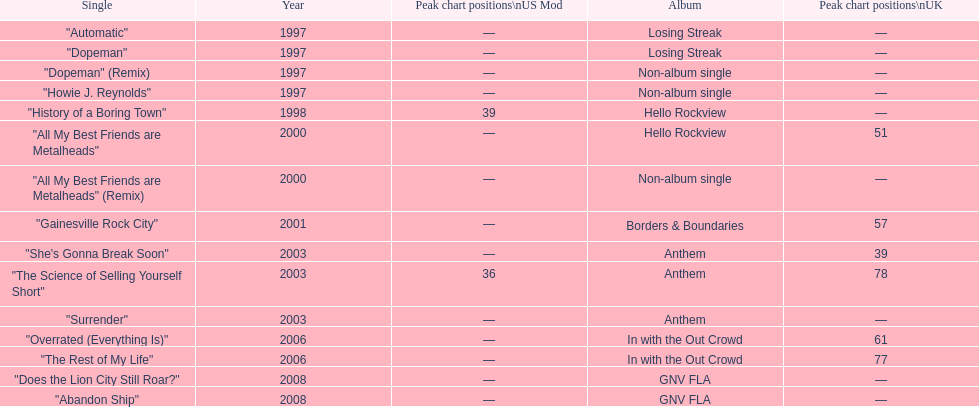Parse the table in full. {'header': ['Single', 'Year', 'Peak chart positions\\nUS Mod', 'Album', 'Peak chart positions\\nUK'], 'rows': [['"Automatic"', '1997', '—', 'Losing Streak', '—'], ['"Dopeman"', '1997', '—', 'Losing Streak', '—'], ['"Dopeman" (Remix)', '1997', '—', 'Non-album single', '—'], ['"Howie J. Reynolds"', '1997', '—', 'Non-album single', '—'], ['"History of a Boring Town"', '1998', '39', 'Hello Rockview', '—'], ['"All My Best Friends are Metalheads"', '2000', '—', 'Hello Rockview', '51'], ['"All My Best Friends are Metalheads" (Remix)', '2000', '—', 'Non-album single', '—'], ['"Gainesville Rock City"', '2001', '—', 'Borders & Boundaries', '57'], ['"She\'s Gonna Break Soon"', '2003', '—', 'Anthem', '39'], ['"The Science of Selling Yourself Short"', '2003', '36', 'Anthem', '78'], ['"Surrender"', '2003', '—', 'Anthem', '—'], ['"Overrated (Everything Is)"', '2006', '—', 'In with the Out Crowd', '61'], ['"The Rest of My Life"', '2006', '—', 'In with the Out Crowd', '77'], ['"Does the Lion City Still Roar?"', '2008', '—', 'GNV FLA', '—'], ['"Abandon Ship"', '2008', '—', 'GNV FLA', '—']]} What was the usual position of their singles on the uk charts? 60.5. 